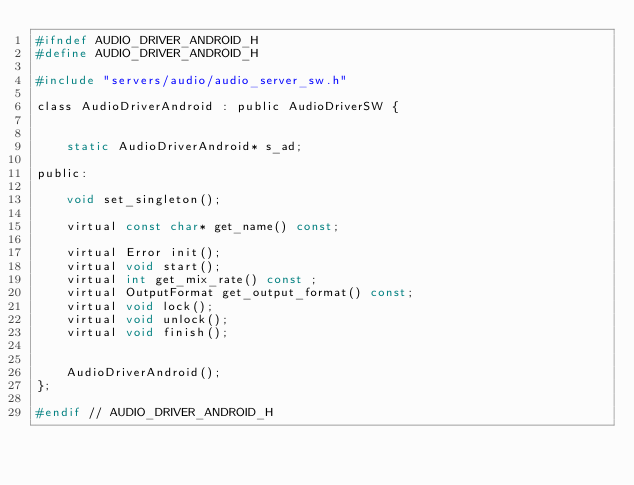<code> <loc_0><loc_0><loc_500><loc_500><_C_>#ifndef AUDIO_DRIVER_ANDROID_H
#define AUDIO_DRIVER_ANDROID_H

#include "servers/audio/audio_server_sw.h"

class AudioDriverAndroid : public AudioDriverSW {


	static AudioDriverAndroid* s_ad;

public:

	void set_singleton();

	virtual const char* get_name() const;

	virtual Error init();
	virtual void start();
	virtual int get_mix_rate() const ;
	virtual OutputFormat get_output_format() const;
	virtual void lock();
	virtual void unlock();
	virtual void finish();


	AudioDriverAndroid();
};

#endif // AUDIO_DRIVER_ANDROID_H
</code> 